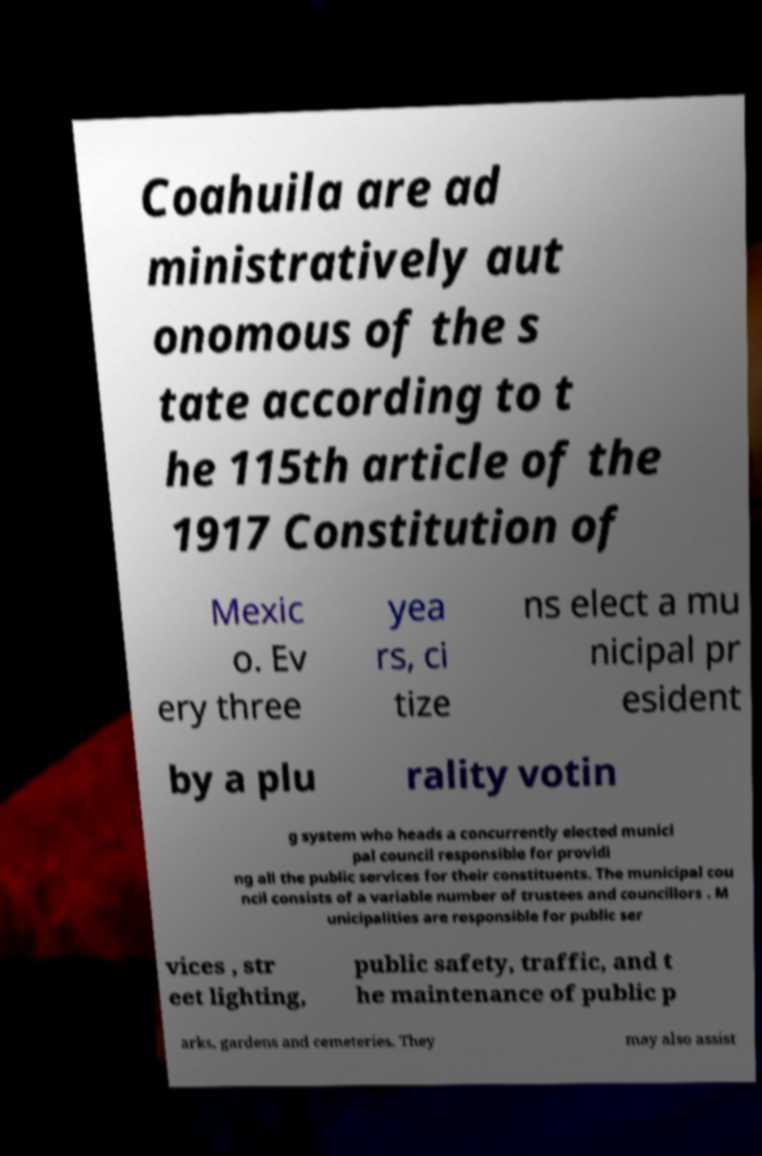Please identify and transcribe the text found in this image. Coahuila are ad ministratively aut onomous of the s tate according to t he 115th article of the 1917 Constitution of Mexic o. Ev ery three yea rs, ci tize ns elect a mu nicipal pr esident by a plu rality votin g system who heads a concurrently elected munici pal council responsible for providi ng all the public services for their constituents. The municipal cou ncil consists of a variable number of trustees and councillors . M unicipalities are responsible for public ser vices , str eet lighting, public safety, traffic, and t he maintenance of public p arks, gardens and cemeteries. They may also assist 